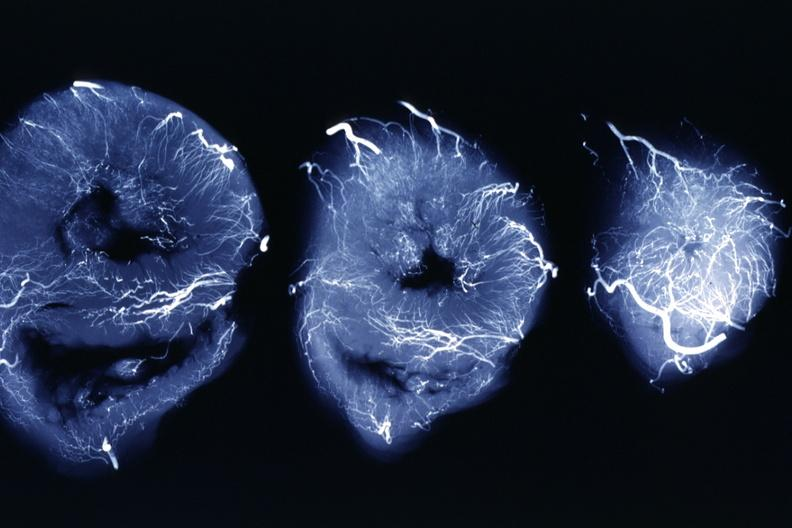s x-ray intramyocardial arteries present?
Answer the question using a single word or phrase. Yes 